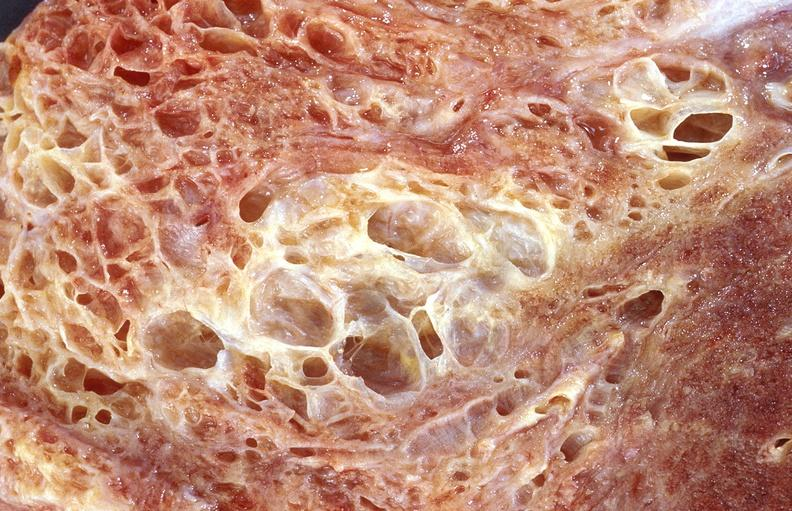s respiratory present?
Answer the question using a single word or phrase. Yes 